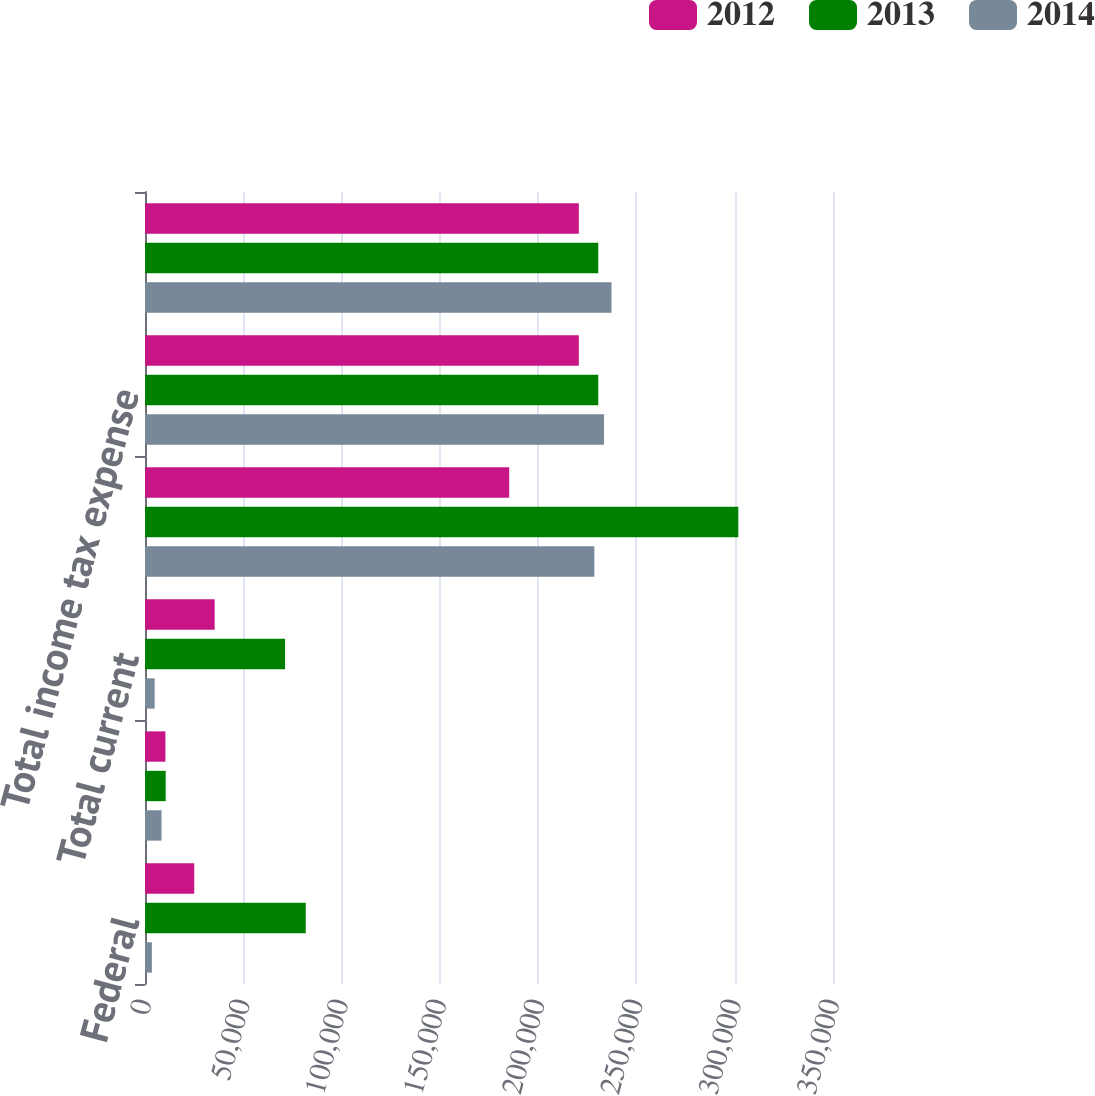<chart> <loc_0><loc_0><loc_500><loc_500><stacked_bar_chart><ecel><fcel>Federal<fcel>State<fcel>Total current<fcel>Total deferred<fcel>Total income tax expense<fcel>Income tax expense -<nl><fcel>2012<fcel>25054<fcel>10382<fcel>35436<fcel>185269<fcel>220705<fcel>220705<nl><fcel>2013<fcel>81784<fcel>10537<fcel>71247<fcel>301838<fcel>230591<fcel>230591<nl><fcel>2014<fcel>3493<fcel>8395<fcel>4902<fcel>228602<fcel>233504<fcel>237317<nl></chart> 